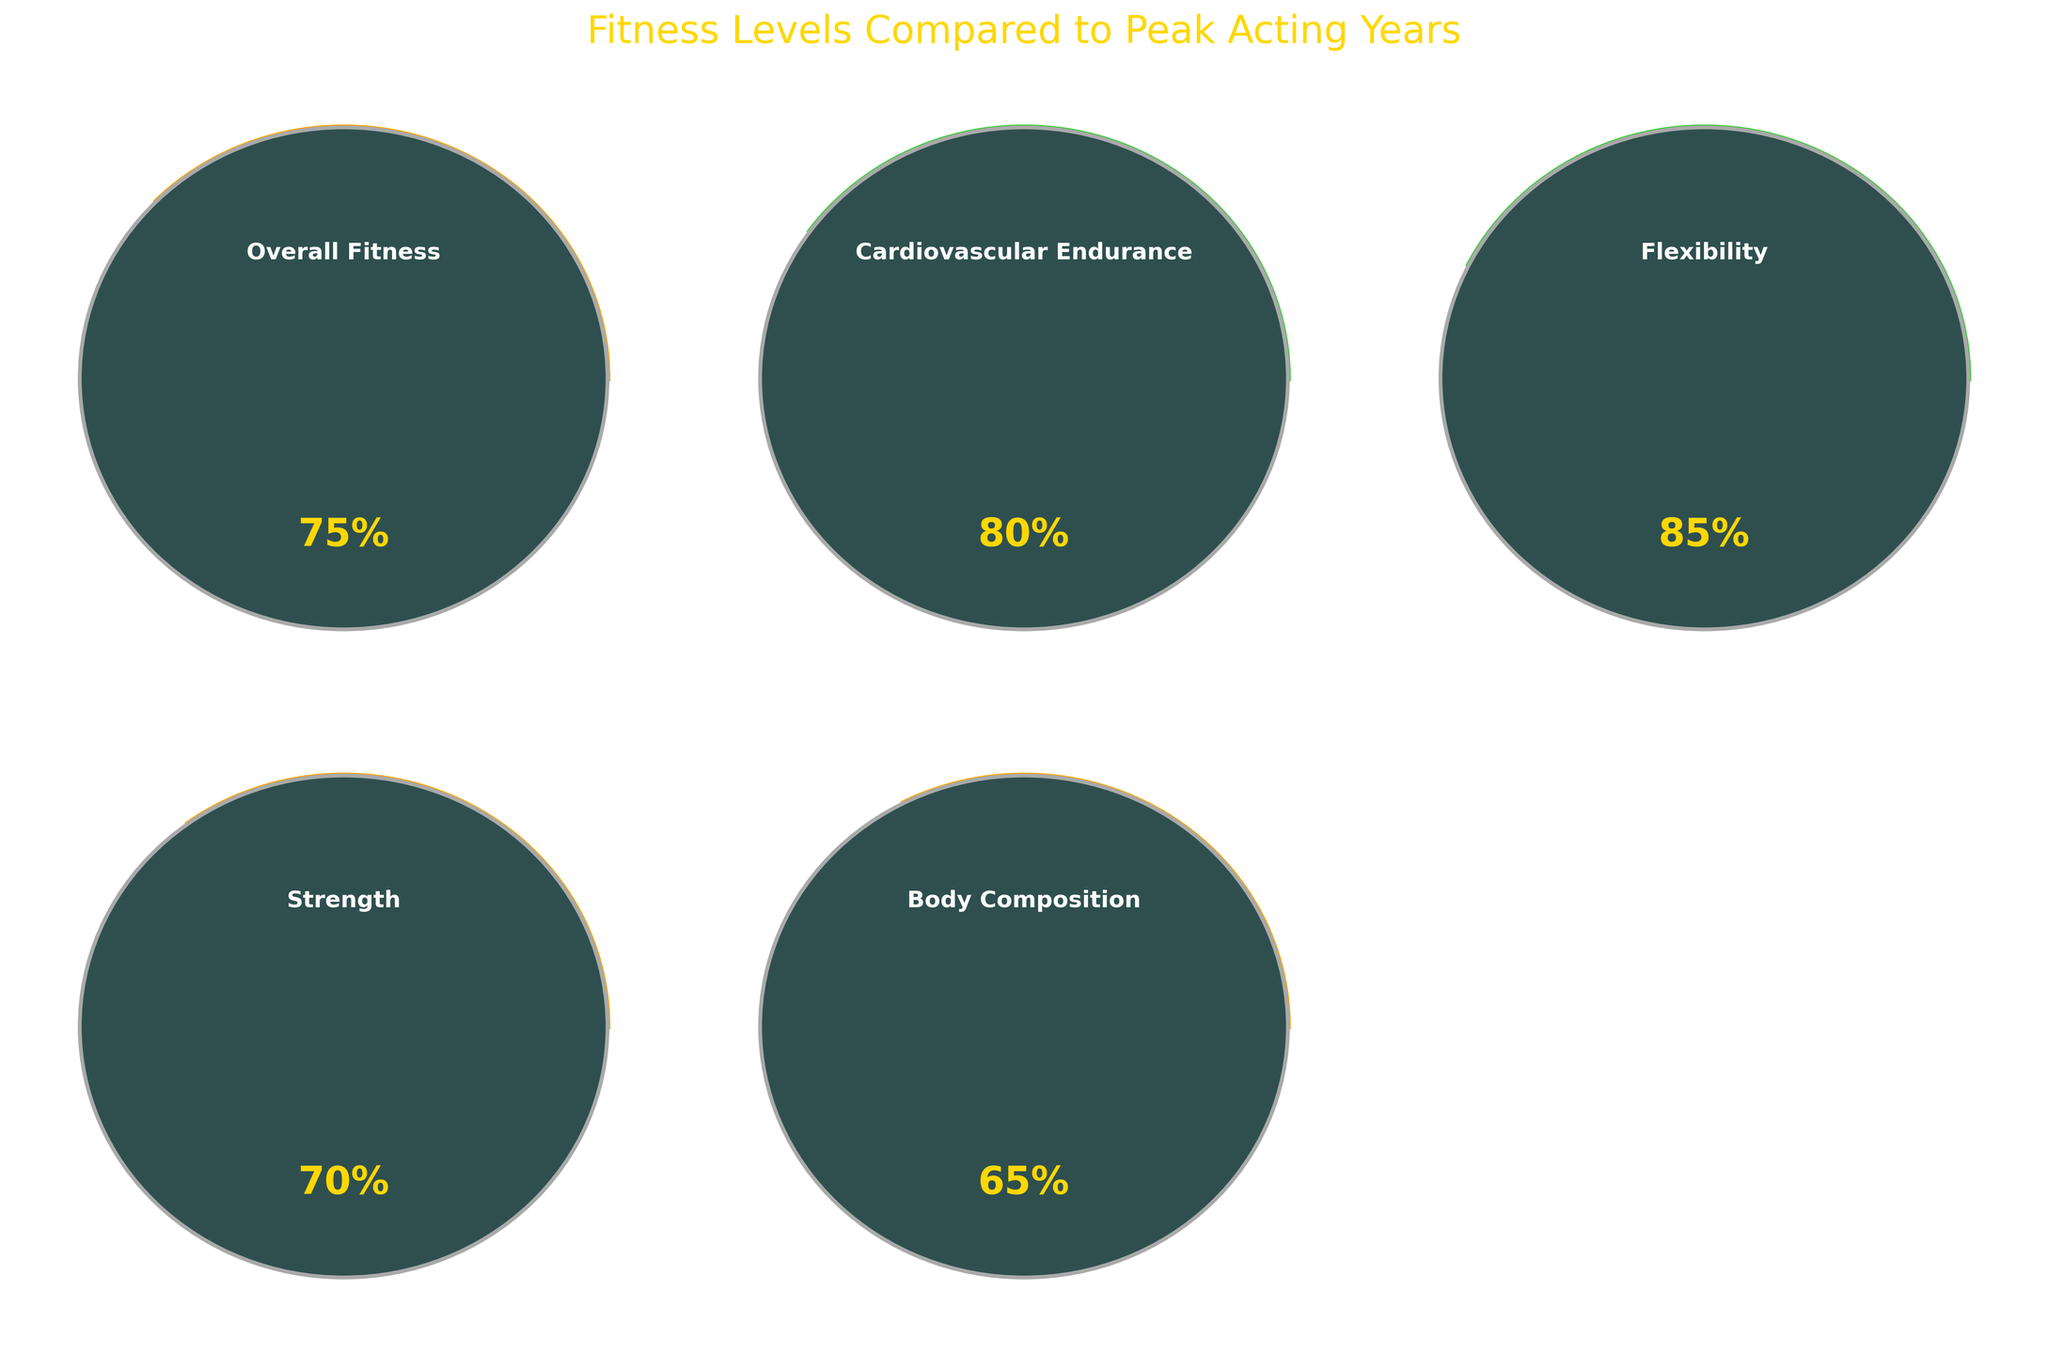What is the title of the figure? The title is located at the top of the figure and is written in a larger font compared to the other text elements.
Answer: Fitness Levels Compared to Peak Acting Years What is the current overall fitness level? The overall fitness gauge is labeled as "Overall Fitness," and the percentage is prominently displayed within the gauge.
Answer: 75% Which category has the highest fitness level? By observing the percentage values displayed within each gauge, Flexibility shows the highest value at 85%.
Answer: Flexibility What is the combined fitness level of Cardiovascular Endurance and Body Composition? To find the combined fitness level, add the percentages for Cardiovascular Endurance (80%) and Body Composition (65%), resulting in 80 + 65.
Answer: 145% Which fitness category is closest in value to the overall fitness level? Comparing each category's value to the overall fitness value of 75%, Cardiovascular Endurance at 80% is closest to 75%.
Answer: Cardiovascular Endurance By how much does the Strength level fall short of Flexibility? Subtract the percentage for Strength (70%) from Flexibility (85%) to find the difference. 85 - 70 = 15%.
Answer: 15% Is the Body Composition fitness level above average compared to the other categories? To determine this, calculate the average of the other categories: (75 + 80 + 85 + 70) / 4 = 77.5. Compare Body Composition (65%) to 77.5%.
Answer: No What color is used for the gauge indicating the Flexibility level? Gauges are colored based on their fitness levels, with Flexibility (85%) in the range that corresponds to green.
Answer: Green What is the difference between the highest and lowest fitness categories? Subtract the lowest percentage (Body Composition at 65%) from the highest percentage (Flexibility at 85%). 85 - 65 = 20%.
Answer: 20% If the average fitness level across all categories is 75%, which categories are below this average? Compare the percentages of all categories to 75%. Body Composition (65%) and Strength (70%) are below 75%.
Answer: Body Composition, Strength 